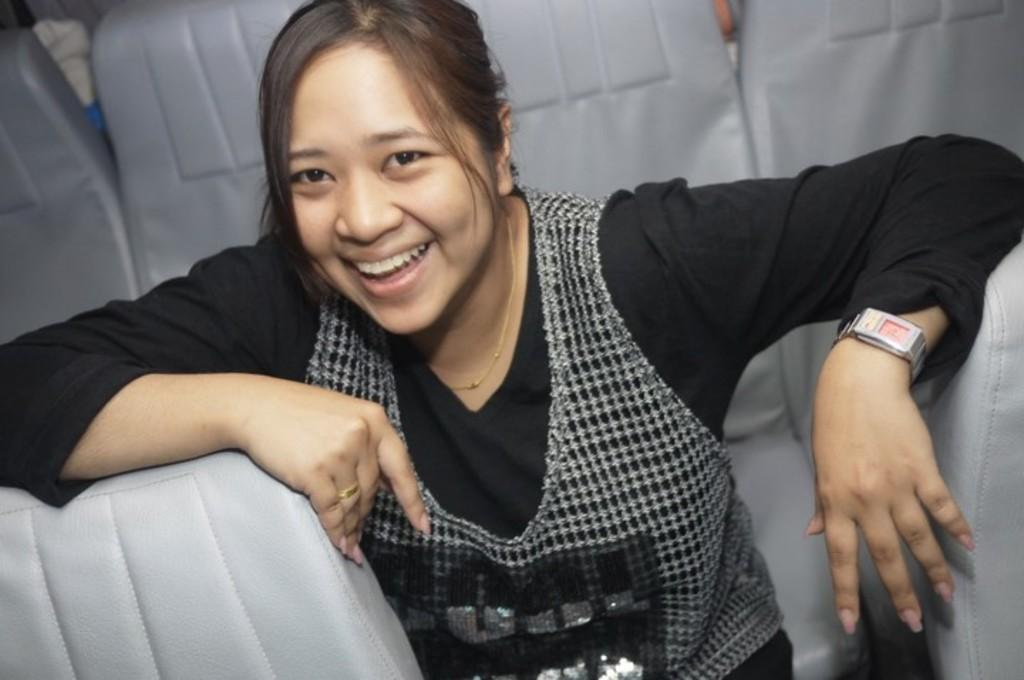What is the main subject of the image? The main subject of the image is a woman. What is the woman doing in the image? The woman is sitting on a chair. What is the woman's facial expression in the image? The woman is smiling. What type of furniture is present in the image? There are chairs in the image. What type of marble is visible on the floor in the image? There is no marble visible on the floor in the image. Is there any blood or meat present in the image? No, there is no blood or meat present in the image. 